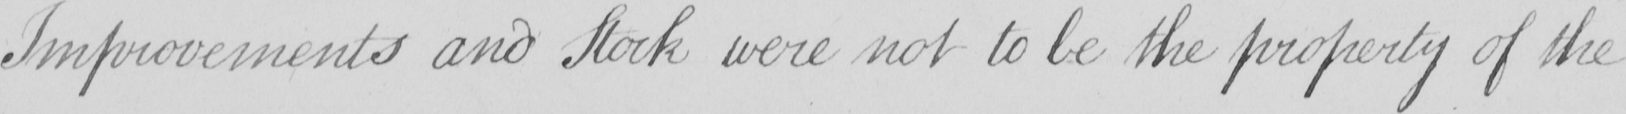Please transcribe the handwritten text in this image. Improvements and Stock were not to be the property of the 